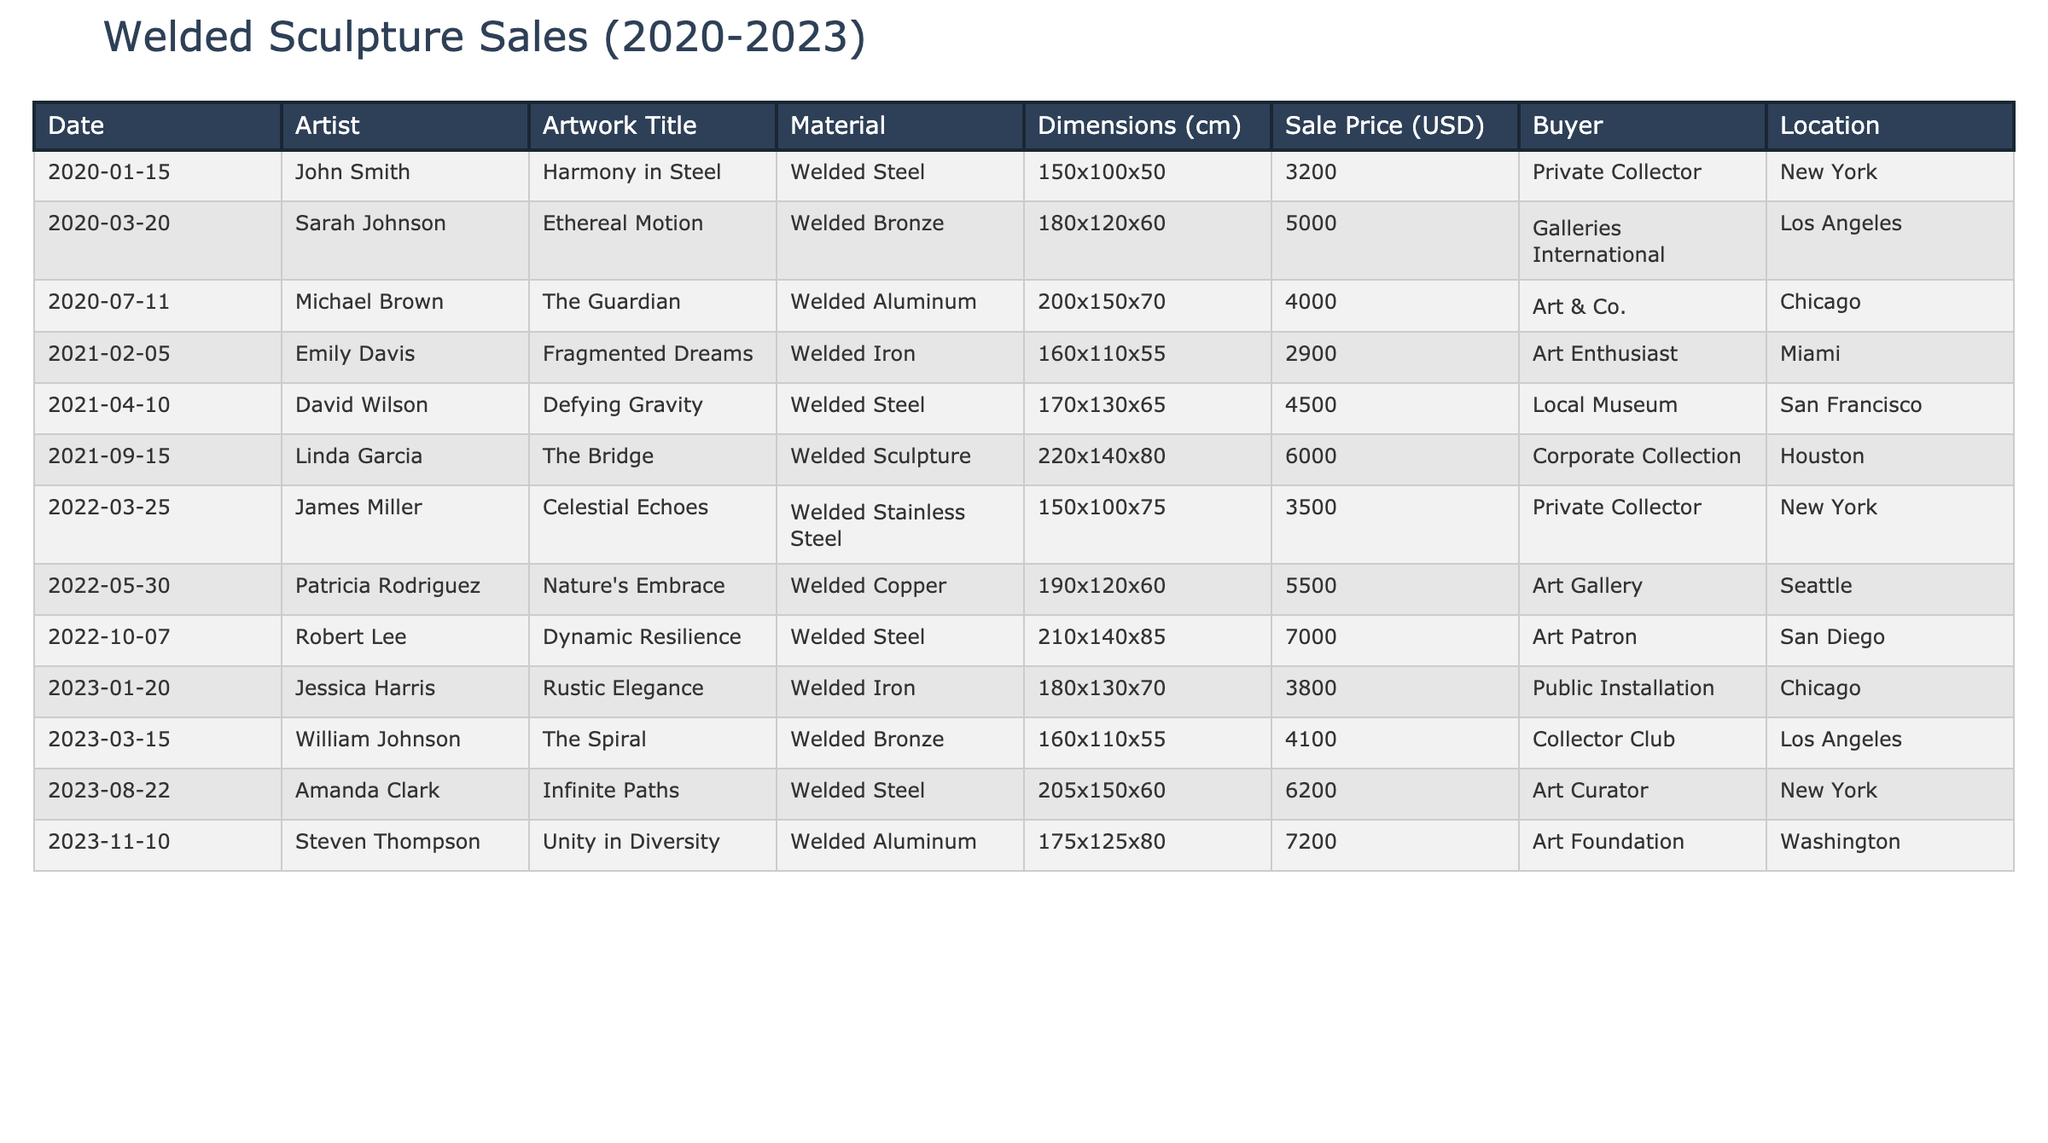What is the highest sale price for a welded sculpture? The highest sale price is $7,200, which is for "Unity in Diversity" by Steven Thompson sold in 2023.
Answer: $7,200 Which artist has the most pieces sold in the gallery? There are multiple artists with one piece sold each, so no artist has multiple pieces sold.
Answer: No artist has multiple pieces sold What is the average sale price of all the welded sculptures from 2020 to 2023? The total sale prices sum to $37,200 and there are 12 pieces sold, so the average is $37,200 / 12 = $3,100.
Answer: $3,100 How many welded sculptures were sold in 2021? In 2021, there were three sales: "Fragmented Dreams," "Defying Gravity," and "The Bridge."
Answer: 3 Did any welded sculpture pieces sell for more than $5,000? Yes, "The Bridge," "Nature's Embrace," "Dynamic Resilience," and "Unity in Diversity" sold for more than $5,000.
Answer: Yes What is the total sale price of the sculptures sold in 2022? The sculptures sold in 2022 are "Celestial Echoes" ($3,500), "Nature's Embrace" ($5,500), and "Dynamic Resilience" ($7,000), summing to $3,500 + $5,500 + $7,000 = $16,000.
Answer: $16,000 Which sculpture has dimensions of “220x140x80”? The sculpture with dimensions “220x140x80” is "The Bridge" by Linda Garcia.
Answer: "The Bridge" What is the total number of unique buyers for the welded sculptures from 2020 to 2023? There are 10 unique buyers mentioned in the table, each represented by their respective purchases.
Answer: 10 Which material generated the highest total sales? The sculptures made of welded steel, specifically "Defying Gravity," "Dynamic Resilience," and "The Spiral," sum to $18,500 in total sales, the highest for any material.
Answer: Welded Steel What percentage of total sales do sculptures sold in New York represent? The total sales in New York are $10,400 from "Harmony in Steel," "Celestial Echoes," and "Infinite Paths," out of a total of $37,200, which is ($10,400 / $37,200) * 100 = 27.95%.
Answer: 27.95% Which sculpture sold first in 2020? The first sculpture sold in 2020 is "Harmony in Steel" on January 15, 2020.
Answer: "Harmony in Steel" 